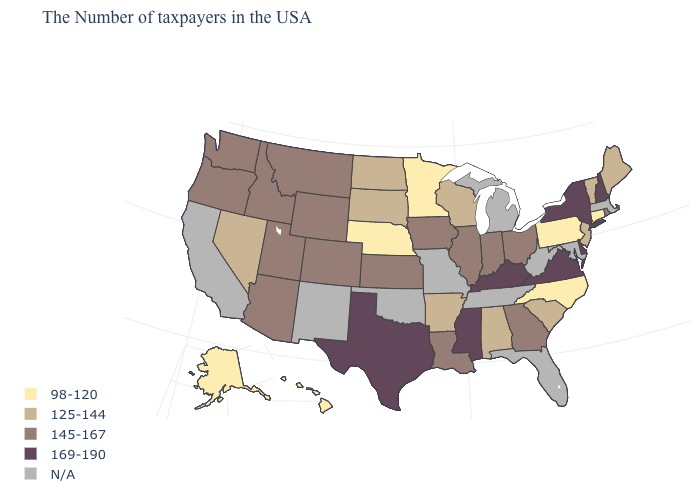What is the highest value in states that border Kentucky?
Concise answer only. 169-190. What is the value of Montana?
Give a very brief answer. 145-167. Name the states that have a value in the range 98-120?
Write a very short answer. Connecticut, Pennsylvania, North Carolina, Minnesota, Nebraska, Alaska, Hawaii. Which states have the lowest value in the West?
Answer briefly. Alaska, Hawaii. What is the highest value in the USA?
Short answer required. 169-190. Which states have the lowest value in the USA?
Short answer required. Connecticut, Pennsylvania, North Carolina, Minnesota, Nebraska, Alaska, Hawaii. Does New Hampshire have the highest value in the Northeast?
Concise answer only. Yes. Among the states that border Montana , does Wyoming have the highest value?
Quick response, please. Yes. Name the states that have a value in the range N/A?
Give a very brief answer. Massachusetts, Maryland, West Virginia, Florida, Michigan, Tennessee, Missouri, Oklahoma, New Mexico, California. What is the value of Hawaii?
Answer briefly. 98-120. Among the states that border Montana , does North Dakota have the highest value?
Quick response, please. No. Among the states that border Ohio , which have the highest value?
Be succinct. Kentucky. What is the value of Maine?
Concise answer only. 125-144. Is the legend a continuous bar?
Keep it brief. No. Does Texas have the highest value in the USA?
Keep it brief. Yes. 